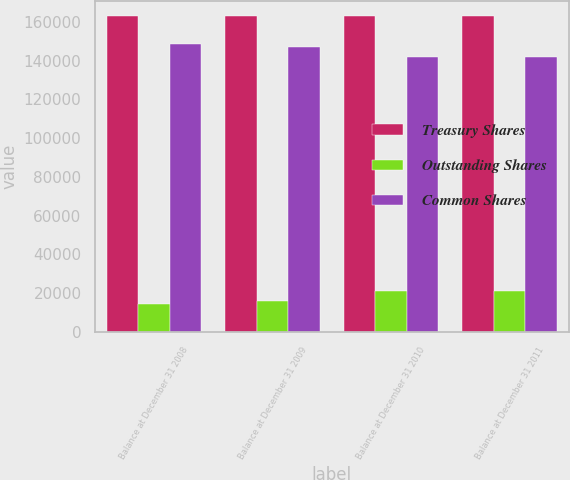Convert chart. <chart><loc_0><loc_0><loc_500><loc_500><stacked_bar_chart><ecel><fcel>Balance at December 31 2008<fcel>Balance at December 31 2009<fcel>Balance at December 31 2010<fcel>Balance at December 31 2011<nl><fcel>Treasury Shares<fcel>162776<fcel>162776<fcel>162776<fcel>162776<nl><fcel>Outstanding Shares<fcel>14248<fcel>15815<fcel>21041<fcel>21144<nl><fcel>Common Shares<fcel>148528<fcel>146961<fcel>141735<fcel>141632<nl></chart> 